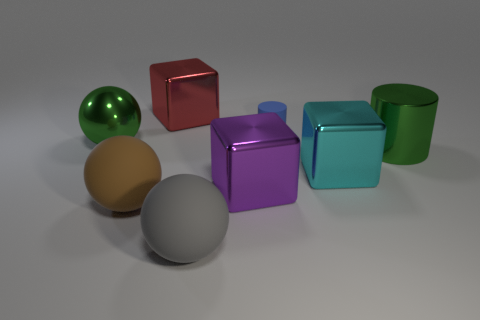Add 1 large red rubber objects. How many objects exist? 9 Subtract all cubes. How many objects are left? 5 Add 6 yellow rubber spheres. How many yellow rubber spheres exist? 6 Subtract 0 blue spheres. How many objects are left? 8 Subtract all big metal balls. Subtract all tiny matte cylinders. How many objects are left? 6 Add 6 cyan shiny cubes. How many cyan shiny cubes are left? 7 